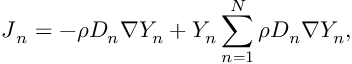Convert formula to latex. <formula><loc_0><loc_0><loc_500><loc_500>J _ { n } = - \rho D _ { n } \nabla Y _ { n } + Y _ { n } \sum _ { n = 1 } ^ { N } \rho D _ { n } \nabla Y _ { n } ,</formula> 